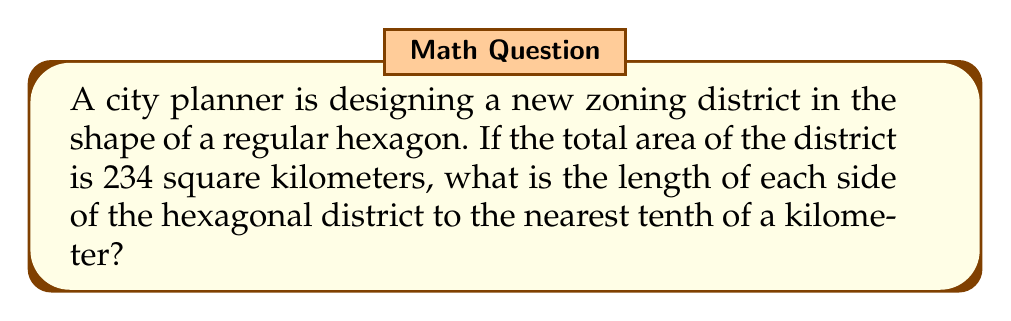Show me your answer to this math problem. Let's approach this step-by-step:

1) The area of a regular hexagon is given by the formula:

   $$A = \frac{3\sqrt{3}}{2}s^2$$

   where $A$ is the area and $s$ is the side length.

2) We know that $A = 234$ km². Let's substitute this into our formula:

   $$234 = \frac{3\sqrt{3}}{2}s^2$$

3) Now, let's solve for $s$:

   $$s^2 = \frac{234 \cdot 2}{3\sqrt{3}}$$

4) Simplify:

   $$s^2 = \frac{468}{3\sqrt{3}} = \frac{156}{\sqrt{3}}$$

5) Take the square root of both sides:

   $$s = \sqrt{\frac{156}{\sqrt{3}}}$$

6) Simplify under the square root:

   $$s = \sqrt{\frac{156}{\sqrt{3}}} = \sqrt{\frac{156 \cdot \sqrt{3}}{3}} = \sqrt{52\sqrt{3}}$$

7) Calculate this value:

   $$s \approx 9.997 \text{ km}$$

8) Rounding to the nearest tenth:

   $$s \approx 10.0 \text{ km}$$

[asy]
unitsize(1cm);
real s = 3;
pair A = (s*sqrt(3)/2, s/2);
pair B = (0, s);
pair C = (-s*sqrt(3)/2, s/2);
pair D = (-s*sqrt(3)/2, -s/2);
pair E = (0, -s);
pair F = (s*sqrt(3)/2, -s/2);
draw(A--B--C--D--E--F--cycle);
label("10.0 km", (A+B)/2, N);
[/asy]
Answer: 10.0 km 